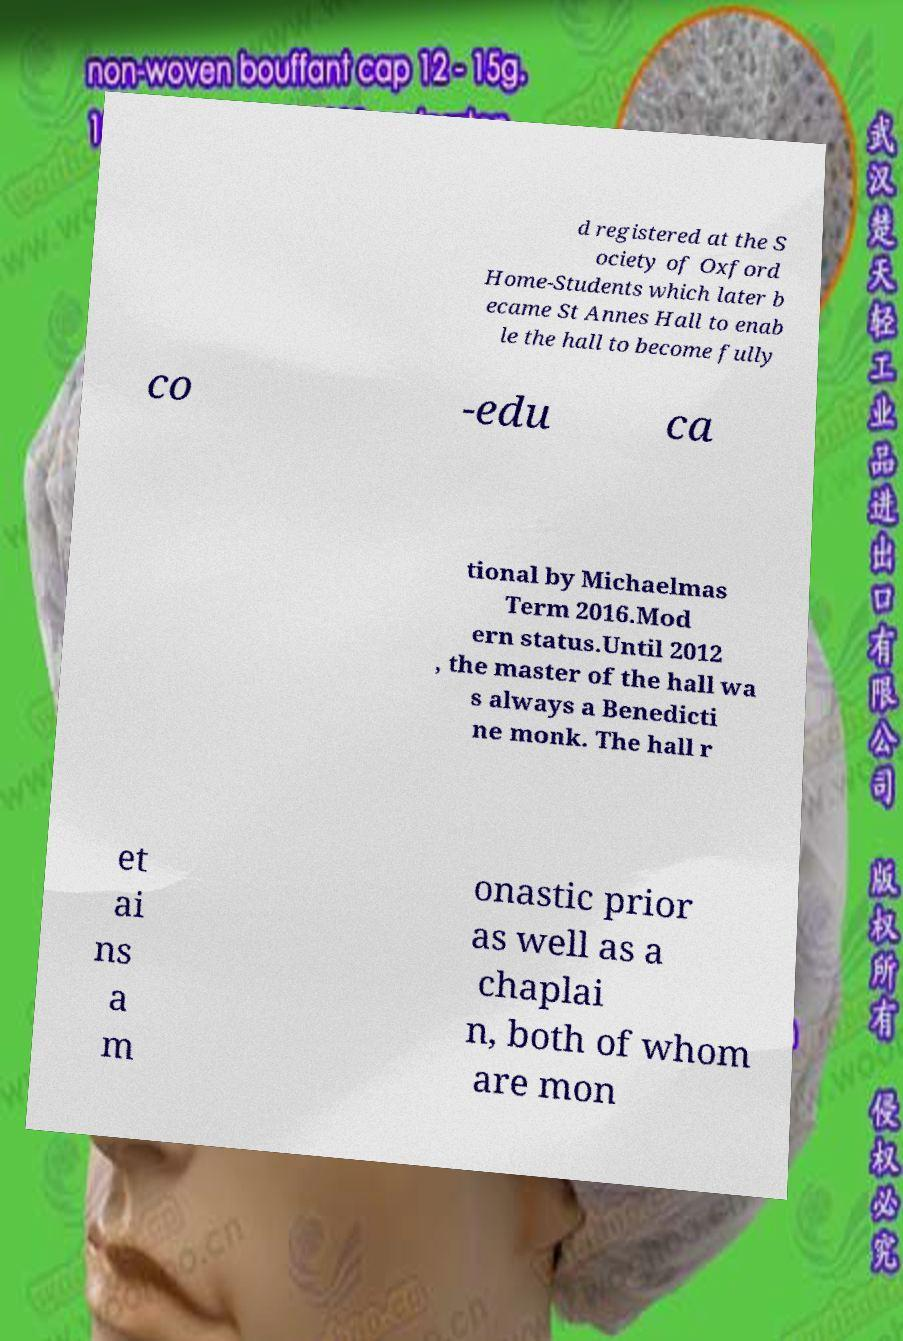Please identify and transcribe the text found in this image. d registered at the S ociety of Oxford Home-Students which later b ecame St Annes Hall to enab le the hall to become fully co -edu ca tional by Michaelmas Term 2016.Mod ern status.Until 2012 , the master of the hall wa s always a Benedicti ne monk. The hall r et ai ns a m onastic prior as well as a chaplai n, both of whom are mon 